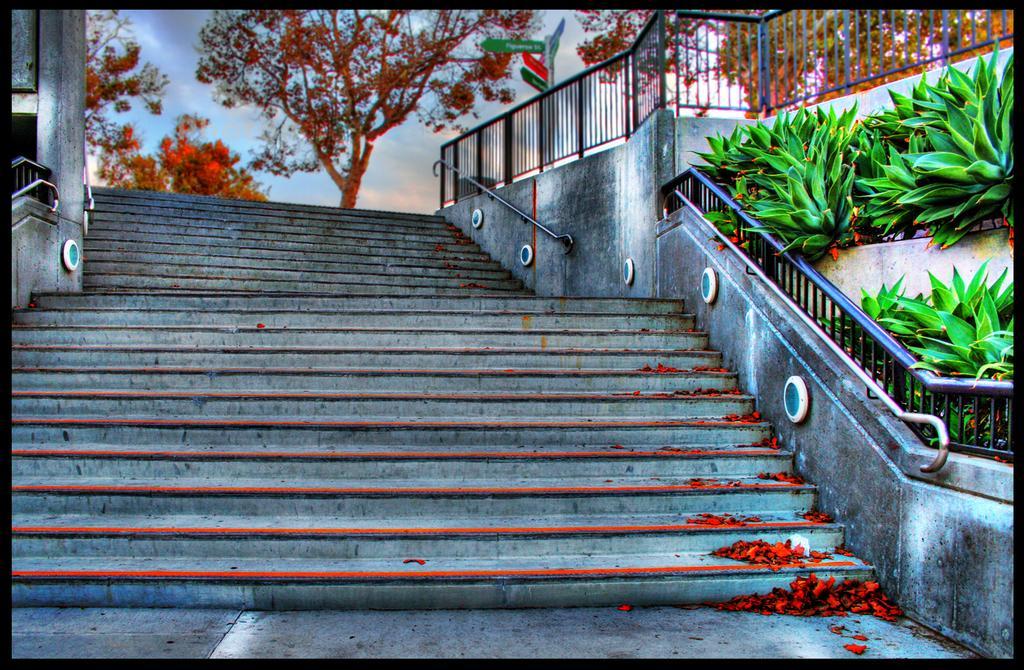Describe this image in one or two sentences. In this image there are steps in the middle. On the right side there are railings. At the bottom there are few flowers on the steps. On the right side top there are plants. At the top there are trees. 